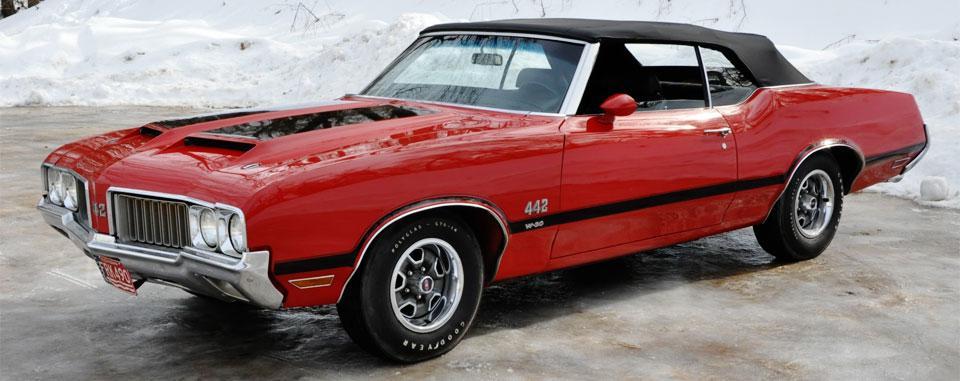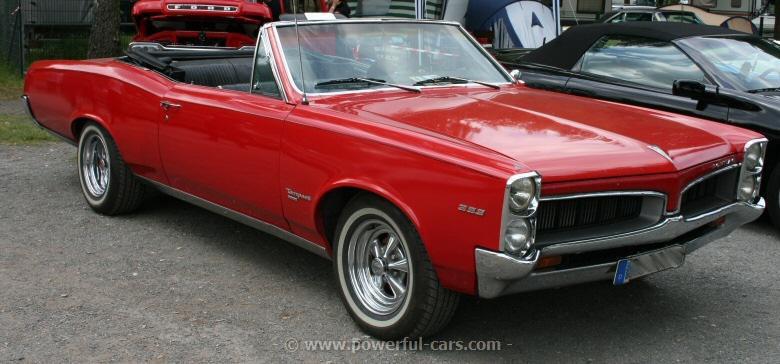The first image is the image on the left, the second image is the image on the right. Evaluate the accuracy of this statement regarding the images: "In each image, the front grille of the car is visible.". Is it true? Answer yes or no. Yes. 